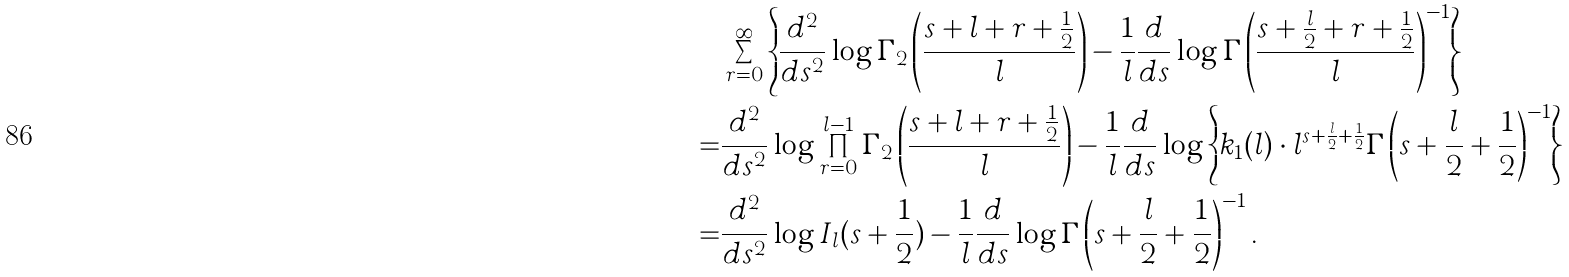Convert formula to latex. <formula><loc_0><loc_0><loc_500><loc_500>& \sum _ { r = 0 } ^ { \infty } \left \{ \frac { d ^ { 2 } } { d s ^ { 2 } } \log \Gamma _ { 2 } \left ( \frac { s + l + r + \frac { 1 } { 2 } } { l } \right ) - \frac { 1 } { l } \frac { d } { d s } \log \Gamma \left ( \frac { s + \frac { l } { 2 } + r + \frac { 1 } { 2 } } { l } \right ) ^ { - 1 } \right \} \\ = & \frac { d ^ { 2 } } { d s ^ { 2 } } \log \prod _ { r = 0 } ^ { l - 1 } \Gamma _ { 2 } \left ( \frac { s + l + r + \frac { 1 } { 2 } } { l } \right ) - \frac { 1 } { l } \frac { d } { d s } \log \left \{ k _ { 1 } ( l ) \cdot l ^ { s + \frac { l } { 2 } + \frac { 1 } { 2 } } \Gamma \left ( s + \frac { l } { 2 } + \frac { 1 } { 2 } \right ) ^ { - 1 } \right \} \\ = & \frac { d ^ { 2 } } { d s ^ { 2 } } \log I _ { l } ( s + \frac { 1 } { 2 } ) - \frac { 1 } { l } \frac { d } { d s } \log \Gamma \left ( s + \frac { l } { 2 } + \frac { 1 } { 2 } \right ) ^ { - 1 } .</formula> 